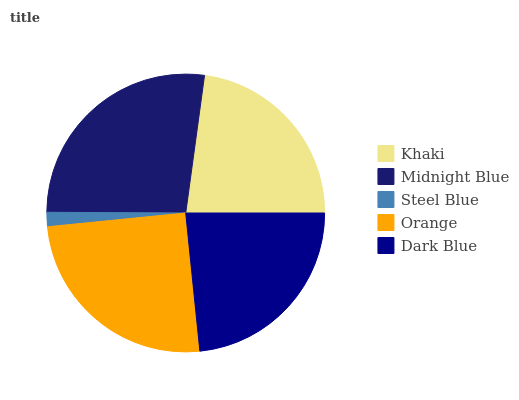Is Steel Blue the minimum?
Answer yes or no. Yes. Is Midnight Blue the maximum?
Answer yes or no. Yes. Is Midnight Blue the minimum?
Answer yes or no. No. Is Steel Blue the maximum?
Answer yes or no. No. Is Midnight Blue greater than Steel Blue?
Answer yes or no. Yes. Is Steel Blue less than Midnight Blue?
Answer yes or no. Yes. Is Steel Blue greater than Midnight Blue?
Answer yes or no. No. Is Midnight Blue less than Steel Blue?
Answer yes or no. No. Is Dark Blue the high median?
Answer yes or no. Yes. Is Dark Blue the low median?
Answer yes or no. Yes. Is Orange the high median?
Answer yes or no. No. Is Midnight Blue the low median?
Answer yes or no. No. 